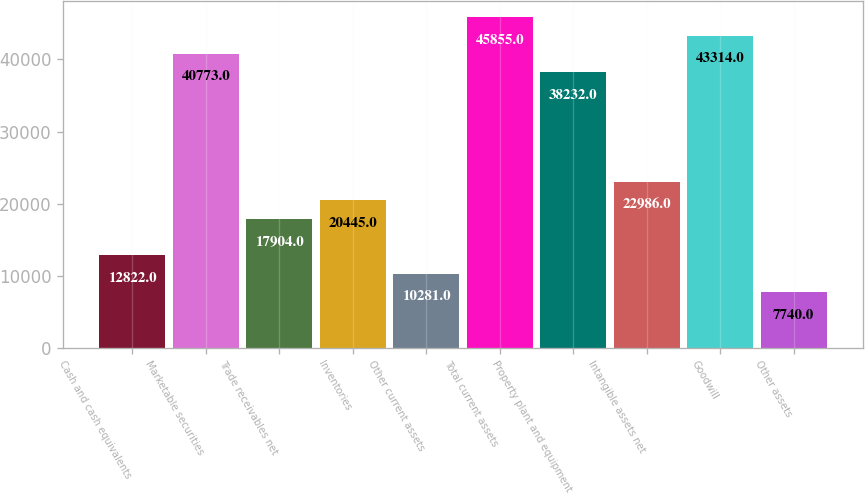<chart> <loc_0><loc_0><loc_500><loc_500><bar_chart><fcel>Cash and cash equivalents<fcel>Marketable securities<fcel>Trade receivables net<fcel>Inventories<fcel>Other current assets<fcel>Total current assets<fcel>Property plant and equipment<fcel>Intangible assets net<fcel>Goodwill<fcel>Other assets<nl><fcel>12822<fcel>40773<fcel>17904<fcel>20445<fcel>10281<fcel>45855<fcel>38232<fcel>22986<fcel>43314<fcel>7740<nl></chart> 